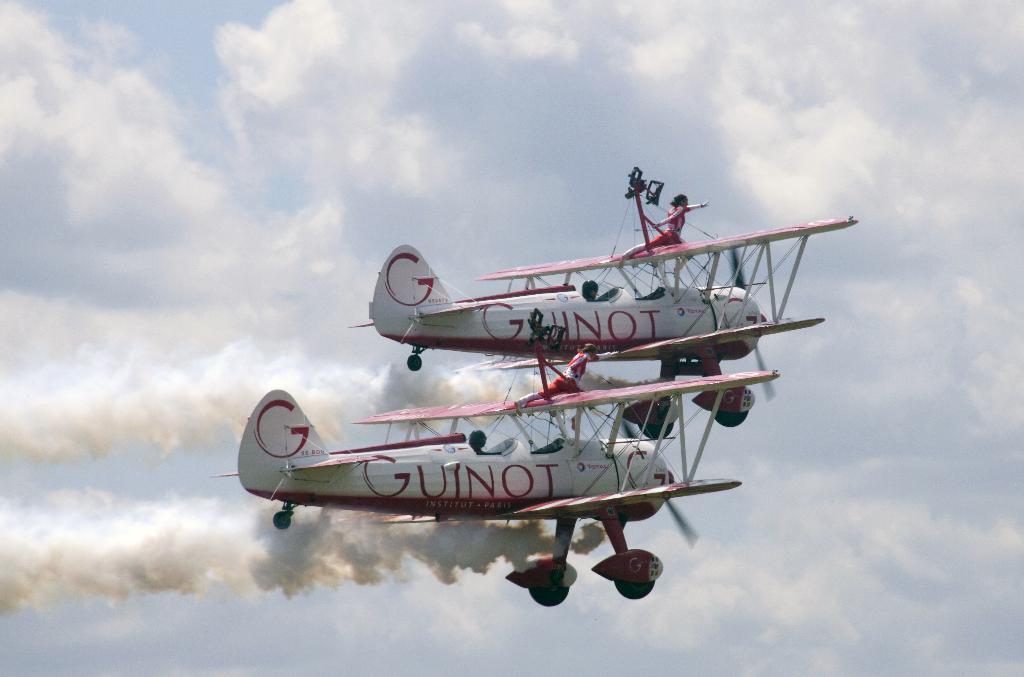What does it say on the plane?
Offer a terse response. Guinot. 